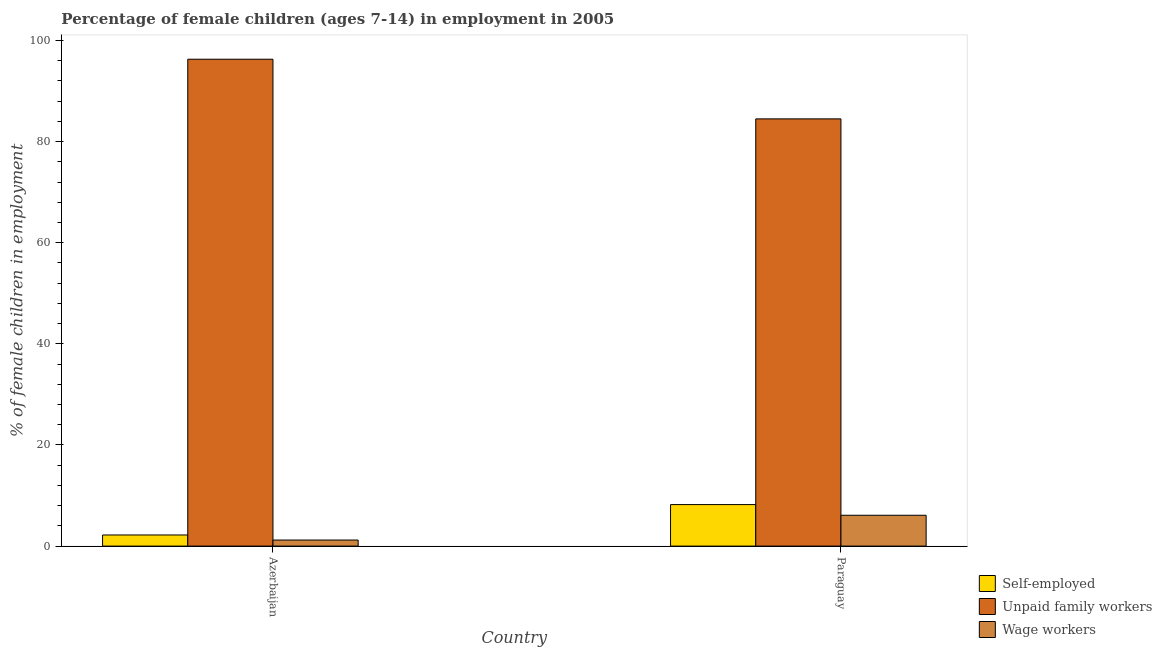How many groups of bars are there?
Keep it short and to the point. 2. Are the number of bars on each tick of the X-axis equal?
Offer a very short reply. Yes. What is the label of the 2nd group of bars from the left?
Make the answer very short. Paraguay. In how many cases, is the number of bars for a given country not equal to the number of legend labels?
Ensure brevity in your answer.  0. Across all countries, what is the maximum percentage of children employed as unpaid family workers?
Make the answer very short. 96.3. Across all countries, what is the minimum percentage of self employed children?
Your answer should be very brief. 2.2. In which country was the percentage of self employed children maximum?
Your response must be concise. Paraguay. In which country was the percentage of self employed children minimum?
Provide a succinct answer. Azerbaijan. What is the total percentage of children employed as wage workers in the graph?
Your response must be concise. 7.3. What is the difference between the percentage of children employed as wage workers in Azerbaijan and that in Paraguay?
Your response must be concise. -4.9. What is the difference between the percentage of children employed as wage workers in Paraguay and the percentage of self employed children in Azerbaijan?
Your response must be concise. 3.9. What is the average percentage of children employed as unpaid family workers per country?
Provide a short and direct response. 90.4. What is the difference between the percentage of self employed children and percentage of children employed as unpaid family workers in Paraguay?
Your response must be concise. -76.29. In how many countries, is the percentage of children employed as wage workers greater than 68 %?
Offer a terse response. 0. What is the ratio of the percentage of children employed as unpaid family workers in Azerbaijan to that in Paraguay?
Your response must be concise. 1.14. Is the percentage of self employed children in Azerbaijan less than that in Paraguay?
Your answer should be very brief. Yes. What does the 2nd bar from the left in Azerbaijan represents?
Your answer should be compact. Unpaid family workers. What does the 1st bar from the right in Paraguay represents?
Offer a very short reply. Wage workers. How many bars are there?
Offer a terse response. 6. Are all the bars in the graph horizontal?
Your answer should be compact. No. Does the graph contain any zero values?
Keep it short and to the point. No. Does the graph contain grids?
Offer a terse response. No. Where does the legend appear in the graph?
Offer a very short reply. Bottom right. How many legend labels are there?
Offer a very short reply. 3. What is the title of the graph?
Your response must be concise. Percentage of female children (ages 7-14) in employment in 2005. Does "Social Insurance" appear as one of the legend labels in the graph?
Your answer should be very brief. No. What is the label or title of the Y-axis?
Provide a succinct answer. % of female children in employment. What is the % of female children in employment of Self-employed in Azerbaijan?
Keep it short and to the point. 2.2. What is the % of female children in employment of Unpaid family workers in Azerbaijan?
Your answer should be compact. 96.3. What is the % of female children in employment in Self-employed in Paraguay?
Make the answer very short. 8.21. What is the % of female children in employment of Unpaid family workers in Paraguay?
Your answer should be very brief. 84.5. What is the % of female children in employment of Wage workers in Paraguay?
Your response must be concise. 6.1. Across all countries, what is the maximum % of female children in employment of Self-employed?
Ensure brevity in your answer.  8.21. Across all countries, what is the maximum % of female children in employment of Unpaid family workers?
Your answer should be very brief. 96.3. Across all countries, what is the maximum % of female children in employment of Wage workers?
Ensure brevity in your answer.  6.1. Across all countries, what is the minimum % of female children in employment of Unpaid family workers?
Keep it short and to the point. 84.5. What is the total % of female children in employment of Self-employed in the graph?
Offer a terse response. 10.41. What is the total % of female children in employment in Unpaid family workers in the graph?
Provide a short and direct response. 180.8. What is the difference between the % of female children in employment of Self-employed in Azerbaijan and that in Paraguay?
Your answer should be very brief. -6.01. What is the difference between the % of female children in employment in Unpaid family workers in Azerbaijan and that in Paraguay?
Offer a terse response. 11.8. What is the difference between the % of female children in employment in Wage workers in Azerbaijan and that in Paraguay?
Keep it short and to the point. -4.9. What is the difference between the % of female children in employment in Self-employed in Azerbaijan and the % of female children in employment in Unpaid family workers in Paraguay?
Your response must be concise. -82.3. What is the difference between the % of female children in employment in Unpaid family workers in Azerbaijan and the % of female children in employment in Wage workers in Paraguay?
Provide a short and direct response. 90.2. What is the average % of female children in employment of Self-employed per country?
Ensure brevity in your answer.  5.21. What is the average % of female children in employment in Unpaid family workers per country?
Provide a succinct answer. 90.4. What is the average % of female children in employment of Wage workers per country?
Your response must be concise. 3.65. What is the difference between the % of female children in employment in Self-employed and % of female children in employment in Unpaid family workers in Azerbaijan?
Give a very brief answer. -94.1. What is the difference between the % of female children in employment of Self-employed and % of female children in employment of Wage workers in Azerbaijan?
Make the answer very short. 1. What is the difference between the % of female children in employment of Unpaid family workers and % of female children in employment of Wage workers in Azerbaijan?
Give a very brief answer. 95.1. What is the difference between the % of female children in employment of Self-employed and % of female children in employment of Unpaid family workers in Paraguay?
Give a very brief answer. -76.29. What is the difference between the % of female children in employment of Self-employed and % of female children in employment of Wage workers in Paraguay?
Your answer should be very brief. 2.11. What is the difference between the % of female children in employment in Unpaid family workers and % of female children in employment in Wage workers in Paraguay?
Give a very brief answer. 78.4. What is the ratio of the % of female children in employment in Self-employed in Azerbaijan to that in Paraguay?
Your answer should be compact. 0.27. What is the ratio of the % of female children in employment of Unpaid family workers in Azerbaijan to that in Paraguay?
Make the answer very short. 1.14. What is the ratio of the % of female children in employment of Wage workers in Azerbaijan to that in Paraguay?
Provide a succinct answer. 0.2. What is the difference between the highest and the second highest % of female children in employment in Self-employed?
Provide a succinct answer. 6.01. What is the difference between the highest and the second highest % of female children in employment of Unpaid family workers?
Your response must be concise. 11.8. What is the difference between the highest and the lowest % of female children in employment of Self-employed?
Make the answer very short. 6.01. 